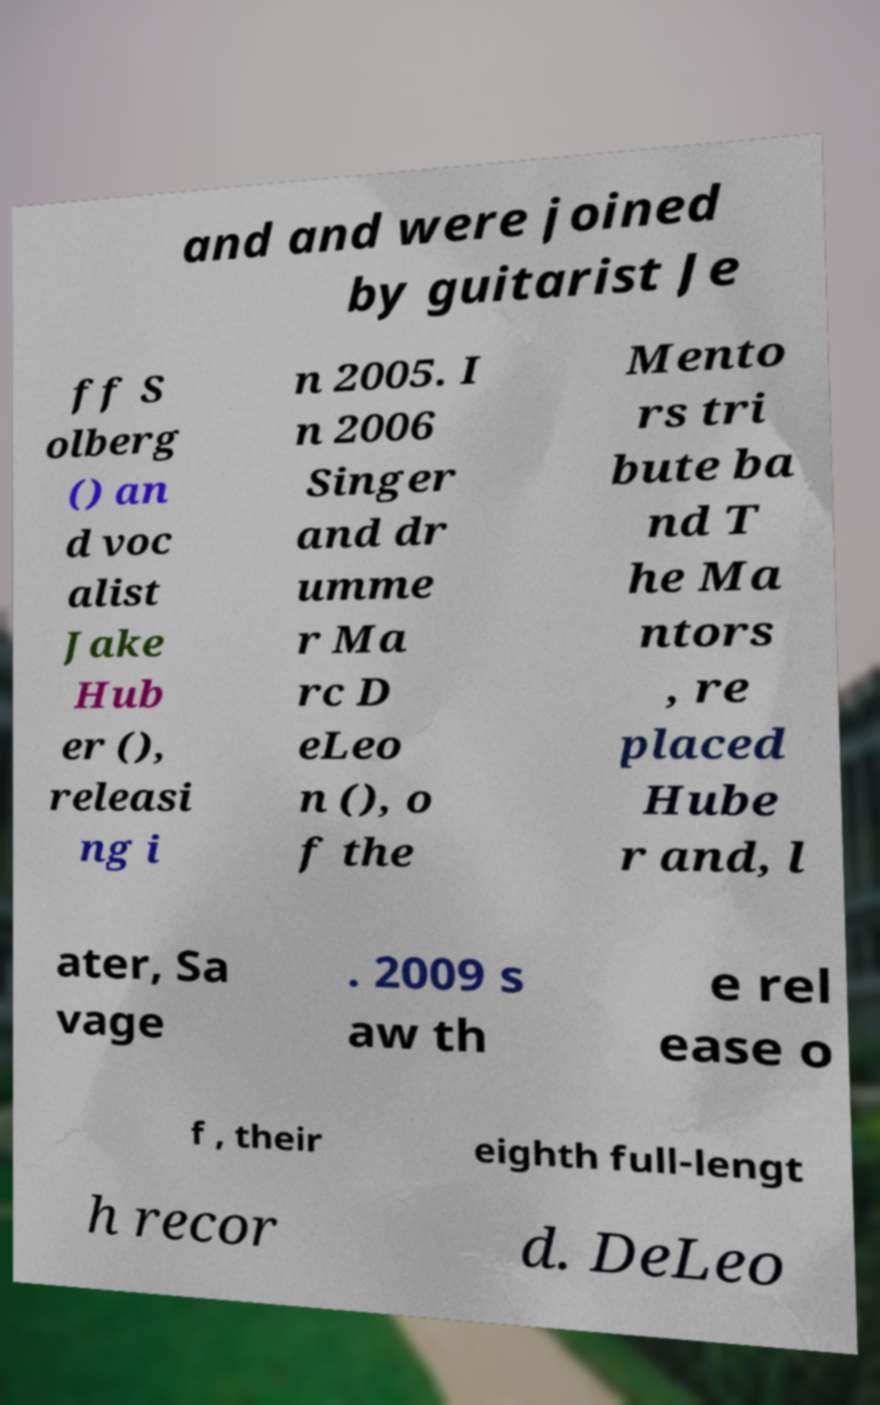Please identify and transcribe the text found in this image. and and were joined by guitarist Je ff S olberg () an d voc alist Jake Hub er (), releasi ng i n 2005. I n 2006 Singer and dr umme r Ma rc D eLeo n (), o f the Mento rs tri bute ba nd T he Ma ntors , re placed Hube r and, l ater, Sa vage . 2009 s aw th e rel ease o f , their eighth full-lengt h recor d. DeLeo 